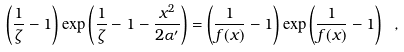Convert formula to latex. <formula><loc_0><loc_0><loc_500><loc_500>\left ( \frac { 1 } { \zeta } - 1 \right ) \exp \left ( \frac { 1 } { \zeta } - 1 - \frac { x ^ { 2 } } { 2 \alpha ^ { \prime } } \right ) = \left ( \frac { 1 } { f ( x ) } - 1 \right ) \exp \left ( \frac { 1 } { f ( x ) } - 1 \right ) \ ,</formula> 